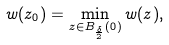<formula> <loc_0><loc_0><loc_500><loc_500>w ( z _ { 0 } ) = \min _ { z \in B _ { \frac { \delta } { 2 } } ( 0 ) } w ( z ) ,</formula> 